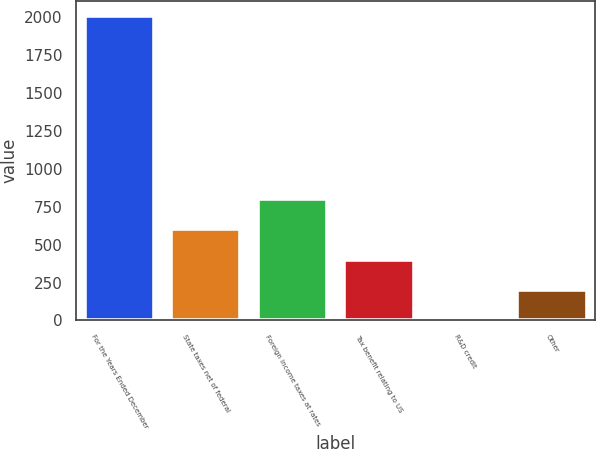Convert chart. <chart><loc_0><loc_0><loc_500><loc_500><bar_chart><fcel>For the Years Ended December<fcel>State taxes net of federal<fcel>Foreign income taxes at rates<fcel>Tax benefit relating to US<fcel>R&D credit<fcel>Other<nl><fcel>2008<fcel>602.47<fcel>803.26<fcel>401.68<fcel>0.1<fcel>200.89<nl></chart> 